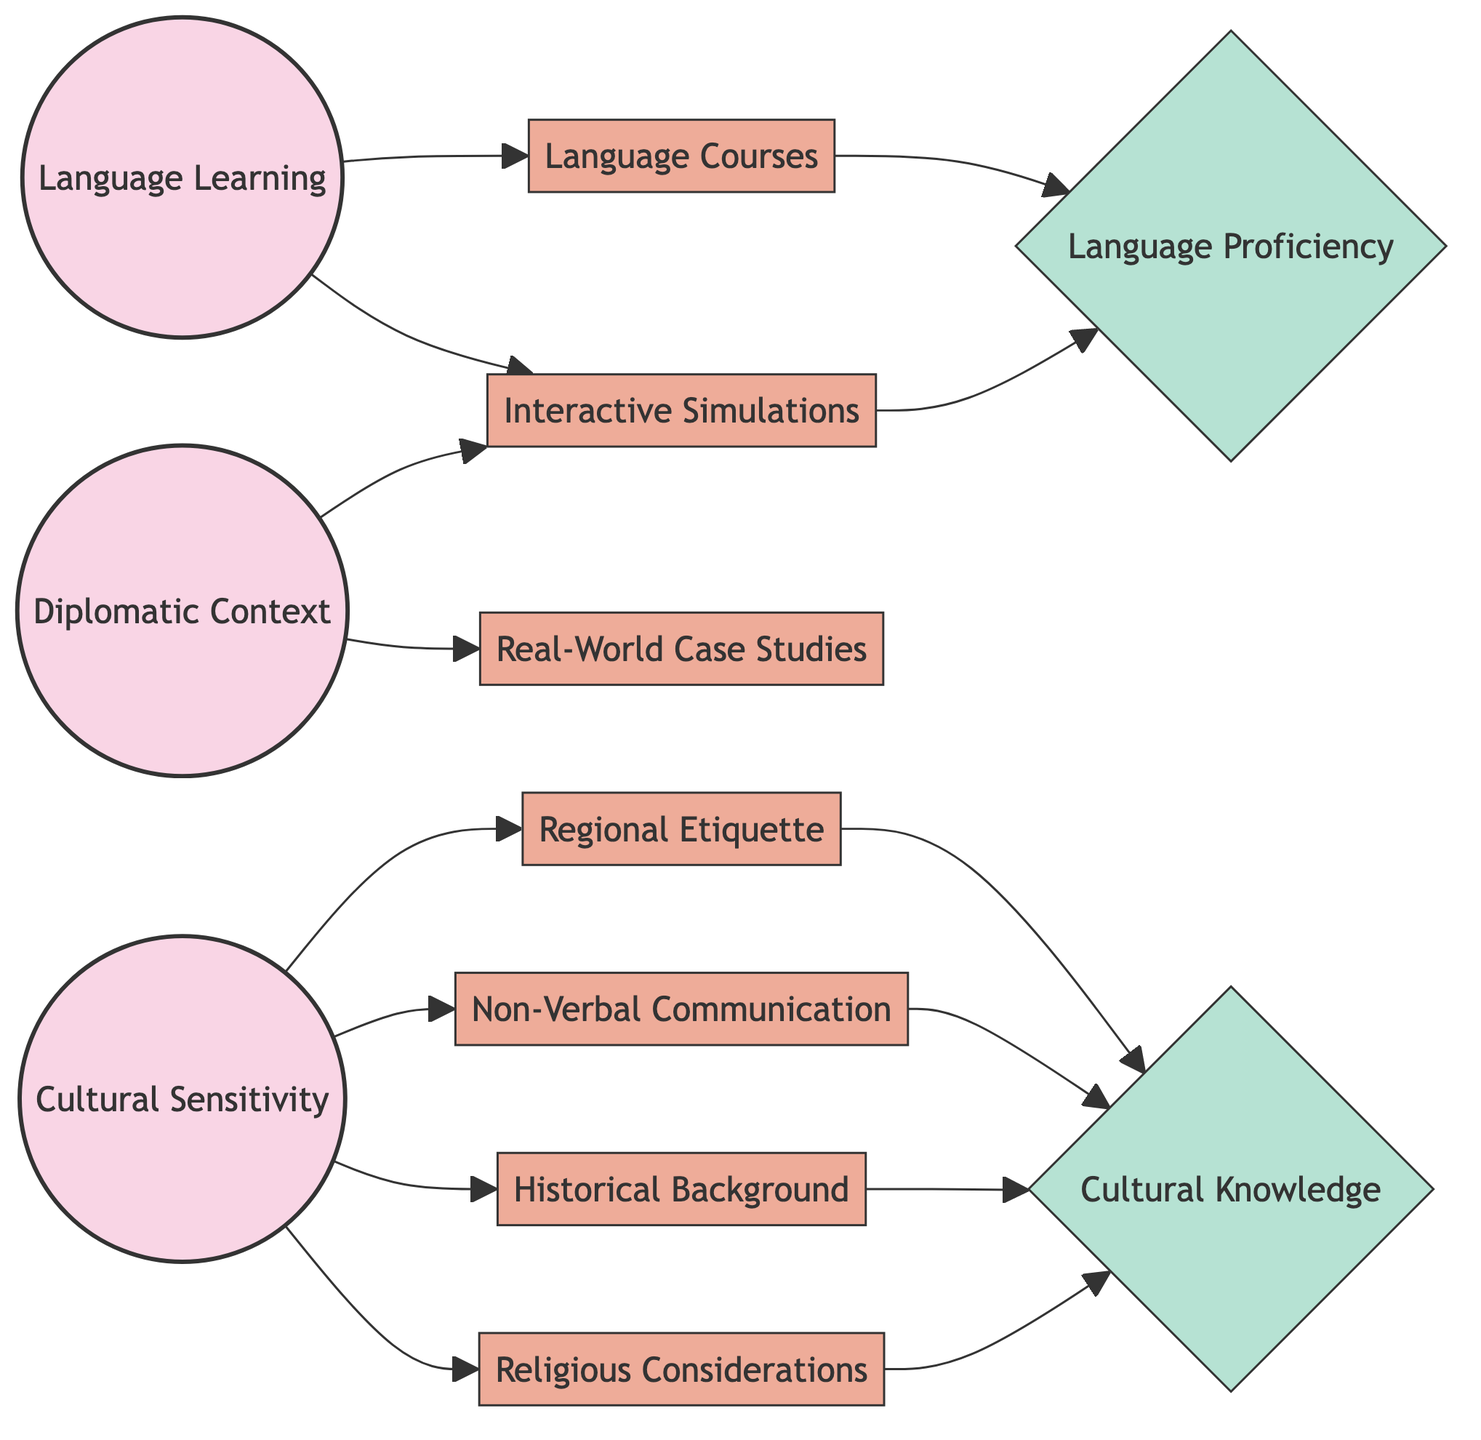What is the total number of nodes in the diagram? The diagram contains a total of 12 nodes, which include core nodes, module nodes, and assessment nodes. I counted each unique node provided in the data section.
Answer: 12 Which module is directly connected to language learning? The modules connected to language learning are language courses and interactive simulations. The diagram shows direct edges from the language learning node to both these modules.
Answer: Language Courses, Interactive Simulations What connects cultural sensitivity to cultural knowledge? Cultural sensitivity connects to cultural knowledge through regional etiquette, non-verbal communication, historical background, and religious considerations. Each of these modules has a direct edge to the cultural knowledge node in the diagram.
Answer: Regional Etiquette, Non-Verbal Communication, Historical Background, Religious Considerations How many modules are associated with cultural sensitivity? There are four modules associated with cultural sensitivity. These modules are regional etiquette, non-verbal communication, historical background, and religious considerations, all of which are shown as edges from the cultural sensitivity node.
Answer: 4 What types of assessments are included in the diagram? The assessments in the diagram include language proficiency and cultural knowledge. These assessments are designated by the data that categorizes them as assessment nodes.
Answer: Language Proficiency, Cultural Knowledge Which node has the most direct connections? The node with the most direct connections is cultural sensitivity, with four outgoing edges leading to regional etiquette, non-verbal communication, historical background, and religious considerations. I determined this by counting the edges directly originating from each node.
Answer: Cultural Sensitivity What is the relationship between diplomatic context and real-world case studies? The diplomatic context node is directly connected to the real-world case studies module, indicating that there is a flow of information or relevance between these two nodes in the context of the diagram.
Answer: Direct connection How does language proficiency connect to the rest of the nodes? Language proficiency is connected to language courses and interactive simulations, which represent different approaches to assessed learning in the context of language learning, creating a pathway leading to the assessment of language skills. Additionally, it is connected to cultural knowledge through various modules.
Answer: Through Language Courses and Interactive Simulations 